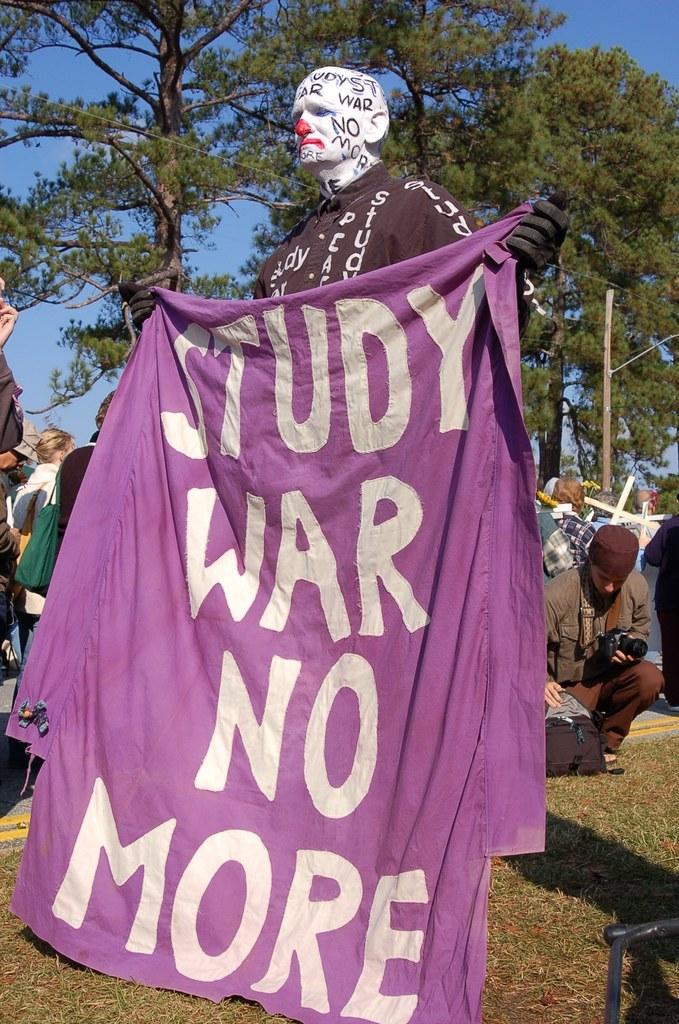Please provide a concise description of this image. In this picture we can see a man with painting on his face and holding a banner with his hands. In the background we can see a group of people, grass, trees, some objects and the sky. 